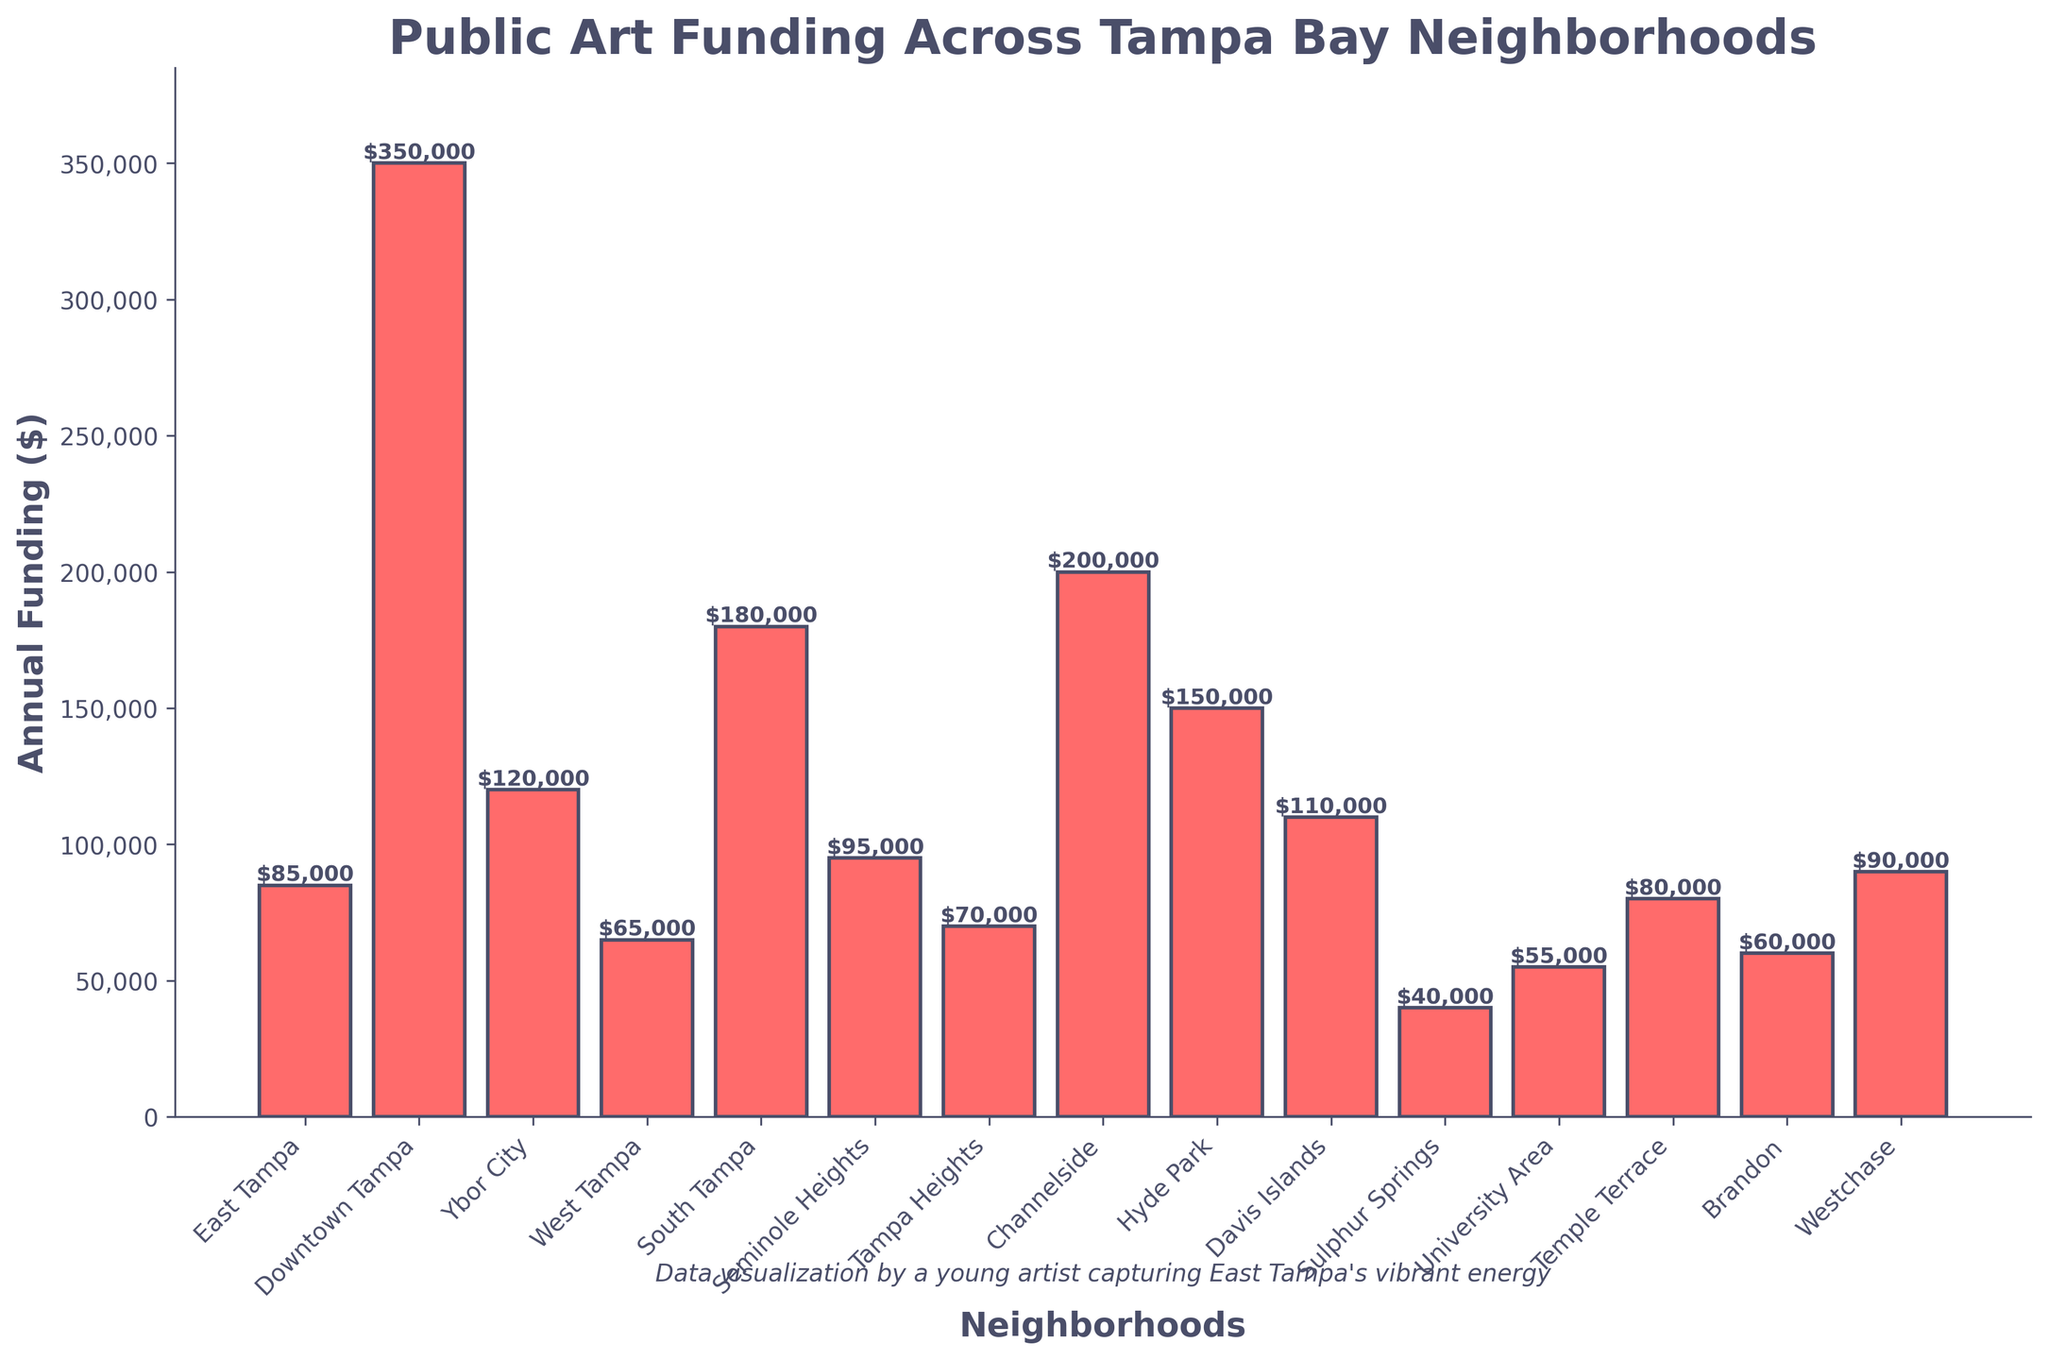Which neighborhood has the highest annual public art funding? The neighborhood with the tallest bar represents the highest funding amount. According to the chart, Downtown Tampa has the tallest bar.
Answer: Downtown Tampa What is the total annual public art funding for East Tampa and Seminole Heights combined? To find the total funding, add the funding amounts of both neighborhoods. East Tampa has $85,000 and Seminole Heights has $95,000. The sum is $85,000 + $95,000 = $180,000.
Answer: $180,000 Which neighborhood receives less funding: West Tampa or Temple Terrace? Compare the heights of the bars for West Tampa and Temple Terrace. West Tampa has $65,000 and Temple Terrace has $80,000. West Tampa receives less funding.
Answer: West Tampa What is the average funding for the neighborhoods with the lowest and highest funding? Identify the neighborhoods with the lowest and highest funding: Sulphur Springs ($40,000) and Downtown Tampa ($350,000). Calculate the average: ($40,000 + $350,000) / 2 = $195,000.
Answer: $195,000 How much more funding does South Tampa receive compared to University Area? Subtract the funding of University Area from South Tampa. South Tampa has $180,000 and University Area has $55,000. The difference is $180,000 - $55,000 = $125,000.
Answer: $125,000 Which two neighborhoods have the closest funding amounts, and what are these amounts? Examine the chart to find the bars with similar heights. West Tampa and Temple Terrace are close, with $65,000 and $80,000 respectively.
Answer: West Tampa ($65,000) and Temple Terrace ($80,000) What is the combined funding for Ybor City, Hyde Park, and Channelside? Sum the funding amounts: Ybor City ($120,000), Hyde Park ($150,000), and Channelside ($200,000). $120,000 + $150,000 + $200,000 = $470,000.
Answer: $470,000 Which has a greater funding difference: between East Tampa and Davis Islands or between Temple Terrace and Brandon? Calculate both differences: 
1. East Tampa ($85,000) and Davis Islands ($110,000): $110,000 - $85,000 = $25,000.
2. Temple Terrace ($80,000) and Brandon ($60,000): $80,000 - $60,000 = $20,000. 
The greater difference is between East Tampa and Davis Islands.
Answer: East Tampa and Davis Islands, $25,000 Which neighborhood falls in the middle in terms of funding when the neighborhoods are listed in descending order? List neighborhoods in descending order of funding and identify the middle value: 
1. Downtown Tampa
2. Channelside
3. South Tampa
4. Hyde Park
5. Ybor City
6. Davis Islands
7. Seminole Heights
8. Westchase
9. Temple Terrace
10. East Tampa
11. Tampa Heights
12. Brandon
13. West Tampa
14. University Area
15. Sulphur Springs
Davis Islands is the middle neighborhood.
Answer: Davis Islands 